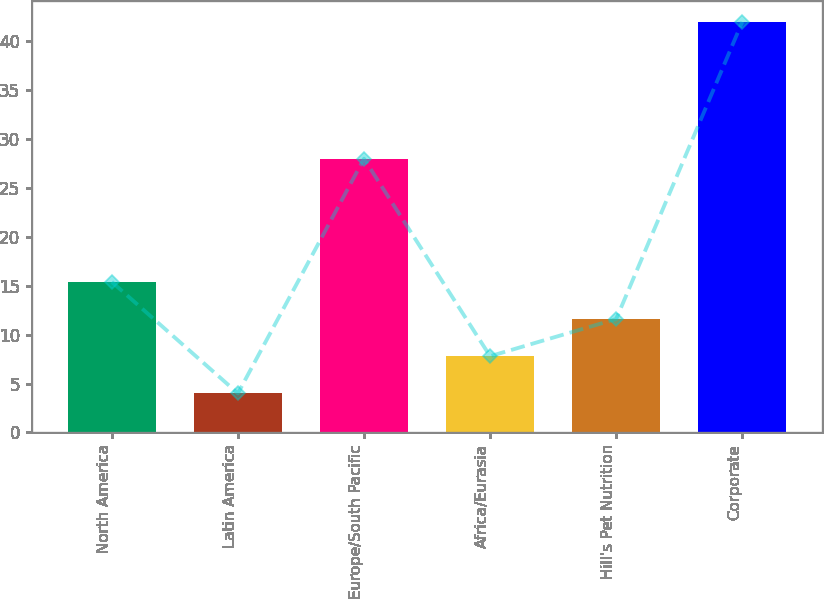<chart> <loc_0><loc_0><loc_500><loc_500><bar_chart><fcel>North America<fcel>Latin America<fcel>Europe/South Pacific<fcel>Africa/Eurasia<fcel>Hill's Pet Nutrition<fcel>Corporate<nl><fcel>15.4<fcel>4<fcel>28<fcel>7.8<fcel>11.6<fcel>42<nl></chart> 